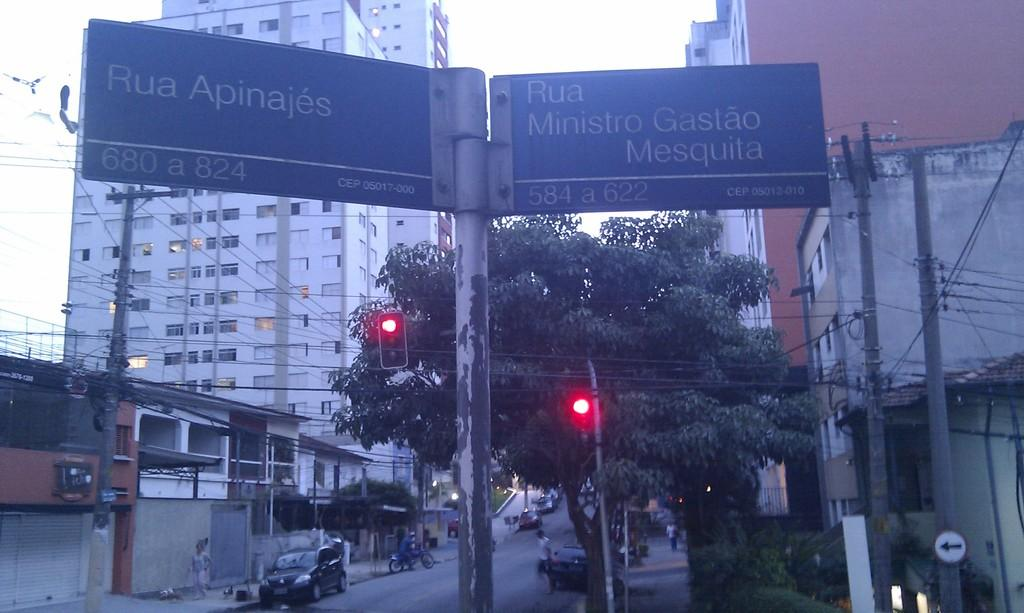<image>
Render a clear and concise summary of the photo. A pair of road signs, the leftmost one which says Rua Apinajes. 